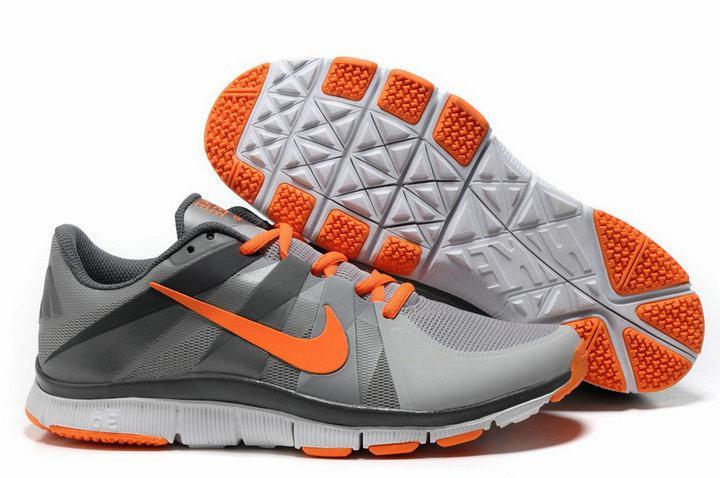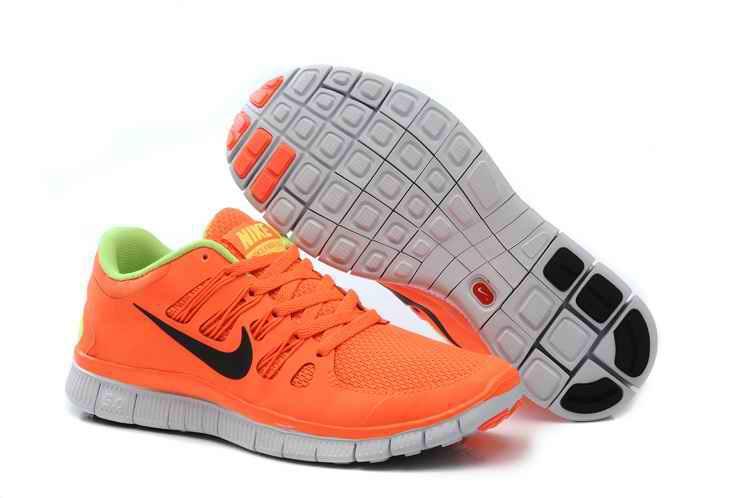The first image is the image on the left, the second image is the image on the right. For the images shown, is this caption "At least one pair of shoes with orange uppers is depicted." true? Answer yes or no. Yes. 